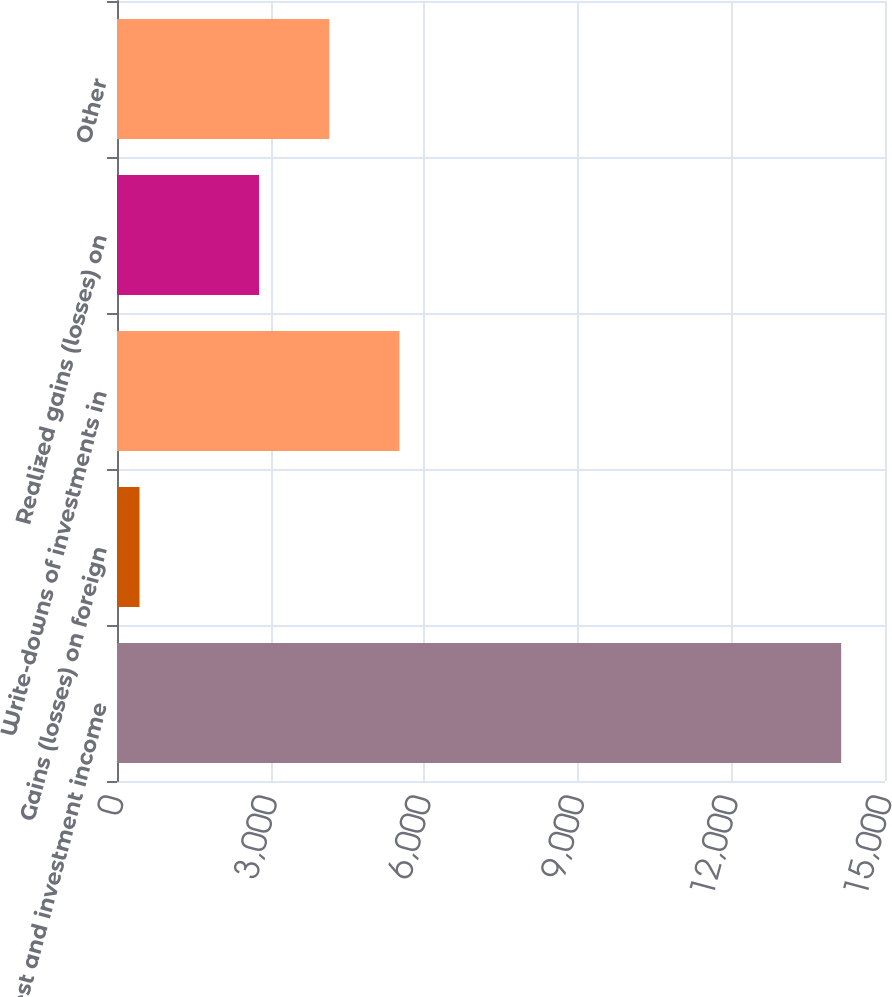Convert chart. <chart><loc_0><loc_0><loc_500><loc_500><bar_chart><fcel>Interest and investment income<fcel>Gains (losses) on foreign<fcel>Write-downs of investments in<fcel>Realized gains (losses) on<fcel>Other<nl><fcel>14144<fcel>440<fcel>5515.8<fcel>2775<fcel>4145.4<nl></chart> 